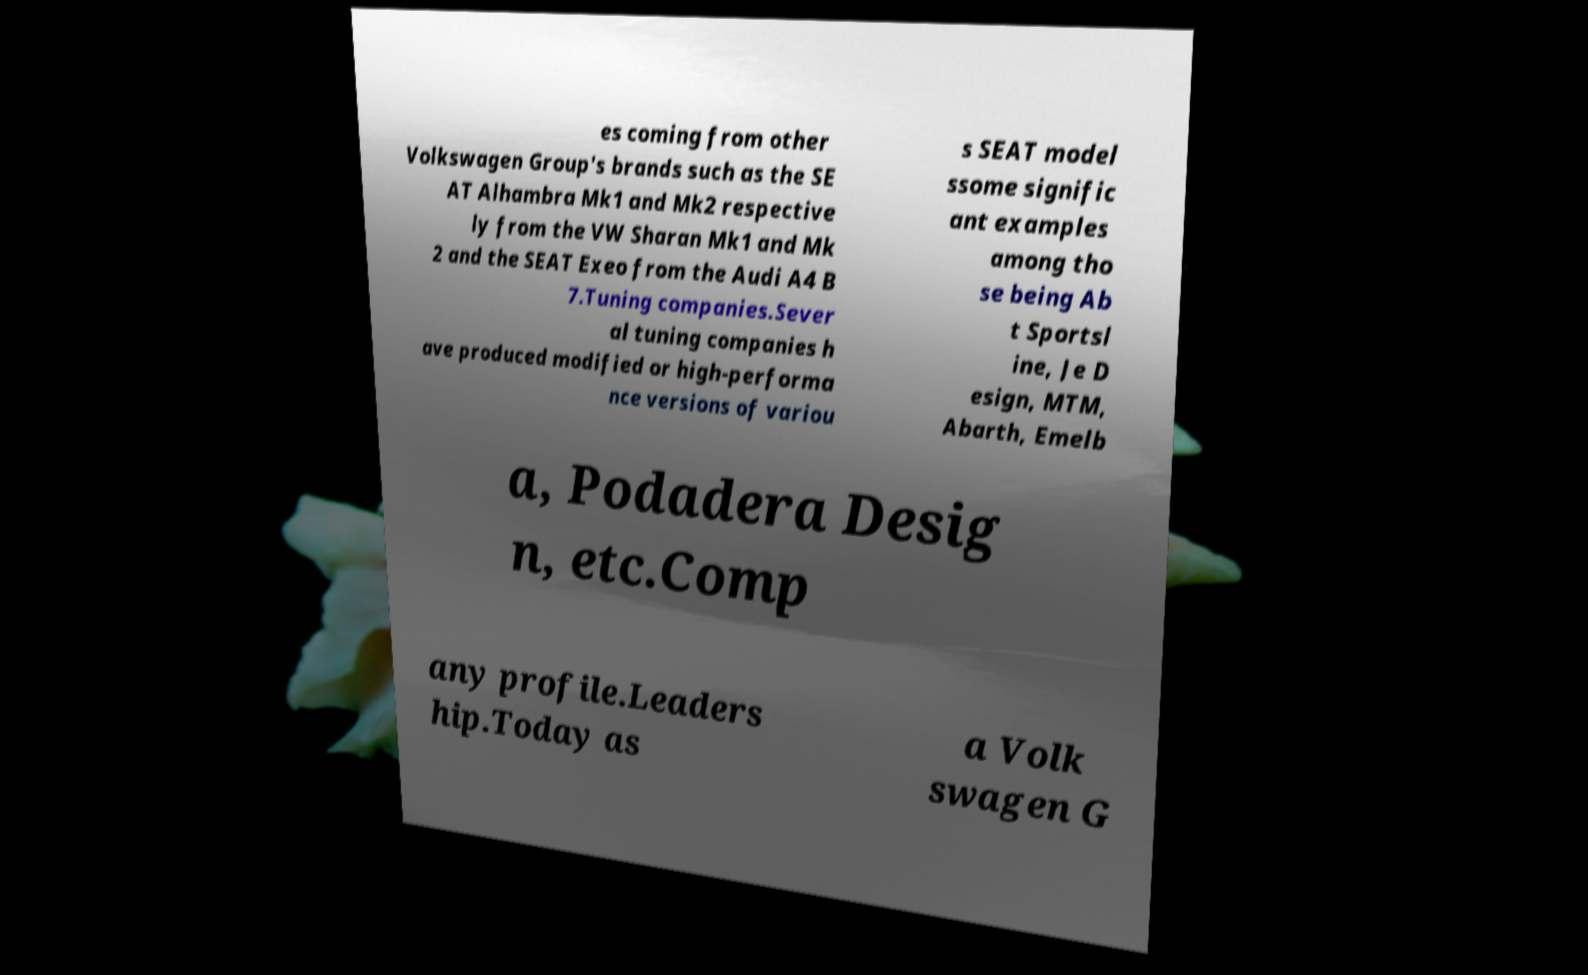There's text embedded in this image that I need extracted. Can you transcribe it verbatim? es coming from other Volkswagen Group's brands such as the SE AT Alhambra Mk1 and Mk2 respective ly from the VW Sharan Mk1 and Mk 2 and the SEAT Exeo from the Audi A4 B 7.Tuning companies.Sever al tuning companies h ave produced modified or high-performa nce versions of variou s SEAT model ssome signific ant examples among tho se being Ab t Sportsl ine, Je D esign, MTM, Abarth, Emelb a, Podadera Desig n, etc.Comp any profile.Leaders hip.Today as a Volk swagen G 